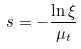<formula> <loc_0><loc_0><loc_500><loc_500>s = - \frac { \ln \xi } { \mu _ { t } }</formula> 